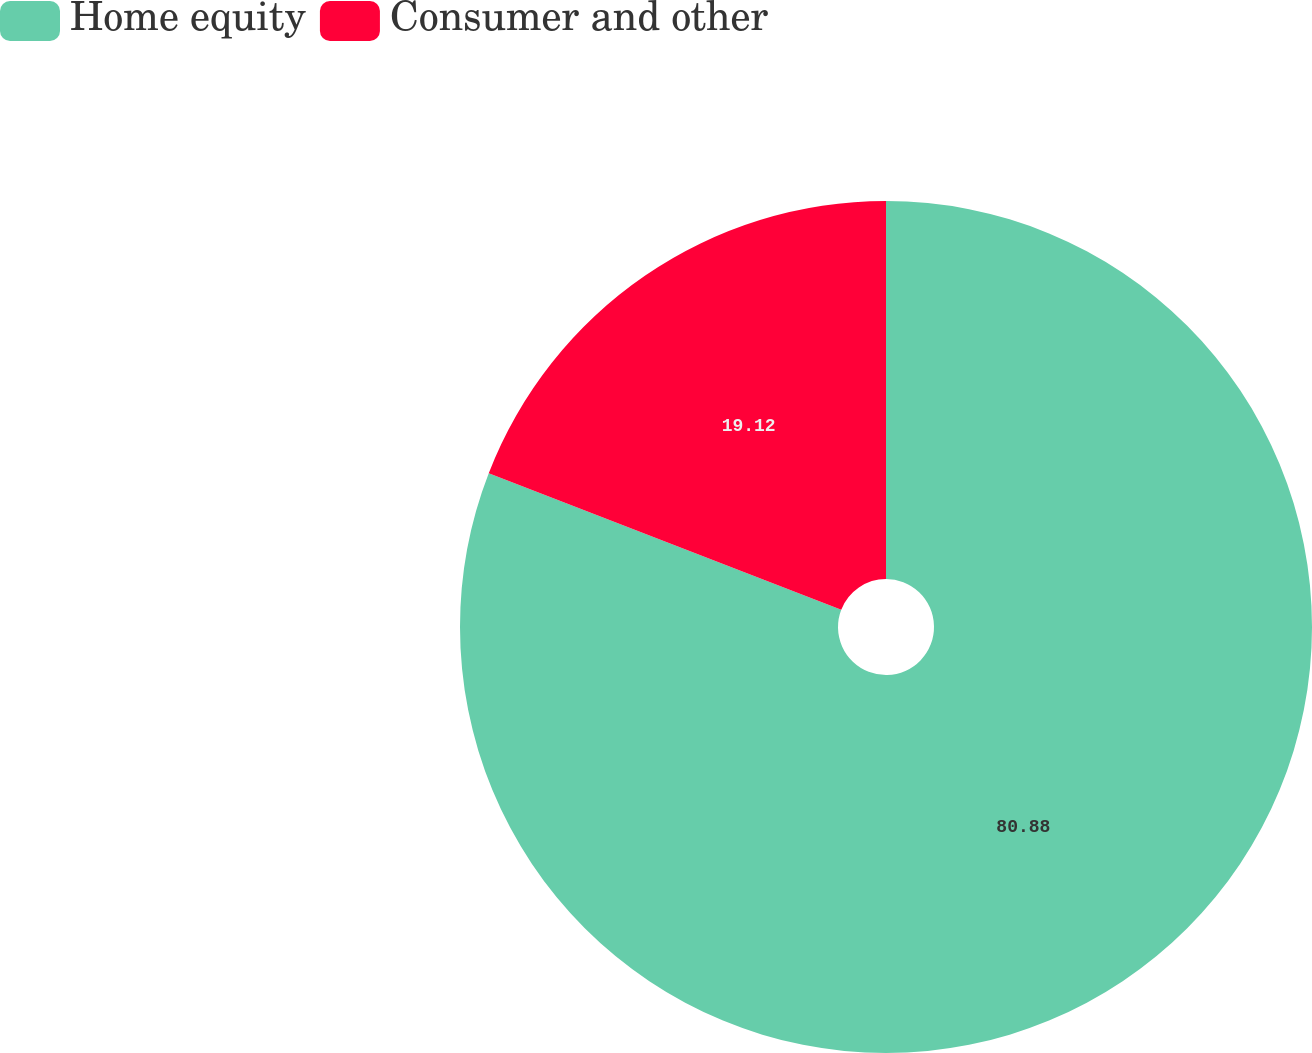Convert chart. <chart><loc_0><loc_0><loc_500><loc_500><pie_chart><fcel>Home equity<fcel>Consumer and other<nl><fcel>80.88%<fcel>19.12%<nl></chart> 